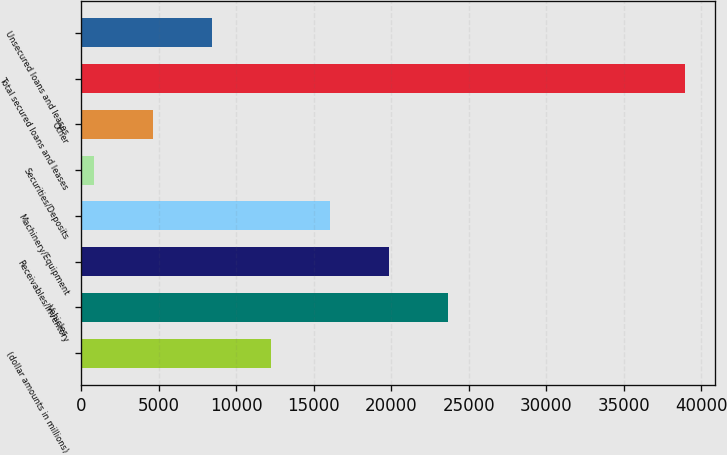Convert chart to OTSL. <chart><loc_0><loc_0><loc_500><loc_500><bar_chart><fcel>(dollar amounts in millions)<fcel>Vehicles<fcel>Receivables/Inventory<fcel>Machinery/Equipment<fcel>Securities/Deposits<fcel>Other<fcel>Total secured loans and leases<fcel>Unsecured loans and leases<nl><fcel>12258.7<fcel>23691.4<fcel>19880.5<fcel>16069.6<fcel>826<fcel>4636.9<fcel>38935<fcel>8447.8<nl></chart> 